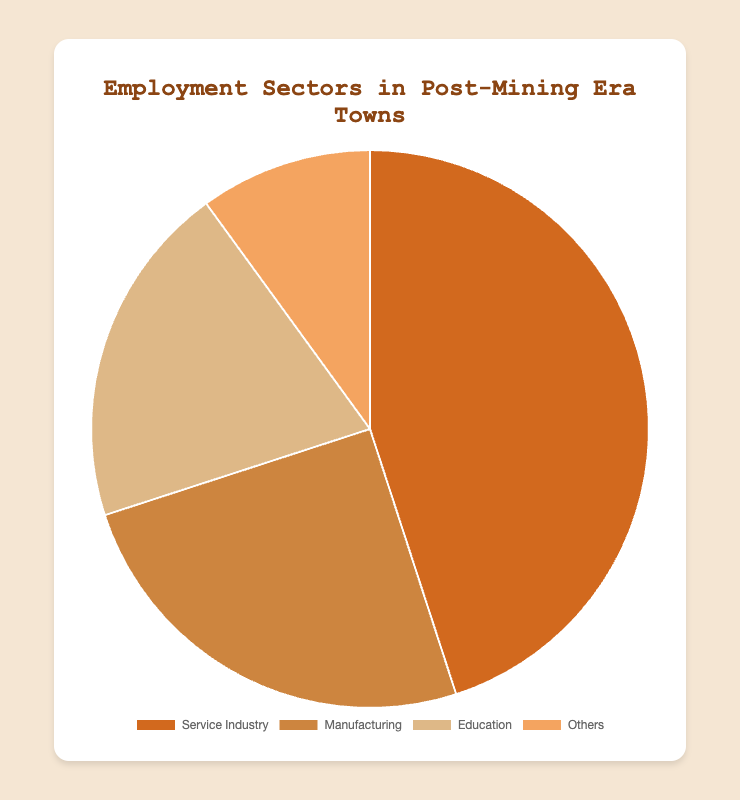What is the largest employment sector in post-mining era towns? The pie chart shows that the Service Industry occupies the largest portion of the pie chart. It has a percentage of 45%.
Answer: Service Industry Which sector has a larger share: Manufacturing or Education? The pie chart shows that Manufacturing has a 25% share, while Education has a 20% share. Comparing these two percentages, Manufacturing has a larger share.
Answer: Manufacturing What percentage of employment falls outside of the three main sectors (Service Industry, Manufacturing, Education)? The pie chart indicates the "Others" category. According to the data, this category represents 10% of the employment.
Answer: 10% How much larger is the Service Industry sector compared to the "Others" sector? The Service Industry is 45%, and "Others" is 10%. The difference can be calculated as 45% - 10% = 35%.
Answer: 35% What is the combined percentage of the Manufacturing and Education sectors? Adding the percentages for Manufacturing (25%) and Education (20%) gives a combined percentage: 25% + 20% = 45%.
Answer: 45% Which sector occupies the smallest portion of the employment sectors? The smallest portion indicated in the pie chart is the "Others" sector, which accounts for 10%.
Answer: Others If the Education sector and the "Others" sector combined, what would be their total percentage? Adding the percentages of Education (20%) and "Others" (10%) results in a total combined percentage: 20% + 10% = 30%.
Answer: 30% How many sectors have a percentage of employment exceeding 20%? The pie chart shows that the Service Industry (45%) and Manufacturing (25%) both exceed 20%. This makes for a total of two sectors.
Answer: 2 What is the difference in employment percentage between the sector with the highest and the sector with the lowest employment? The Service Industry has the highest employment at 45%, and the "Others" sector has the lowest at 10%. The difference is calculated as 45% - 10% = 35%.
Answer: 35% If you were to group Manufacturing and Education together, would their combined employment percentage be higher or lower than the Service Industry? Manufacturing and Education together make up 25% + 20% = 45%, which is equal to the Service Industry's 45%. Therefore, their combined percentage is equal to that of the Service Industry.
Answer: Equal 